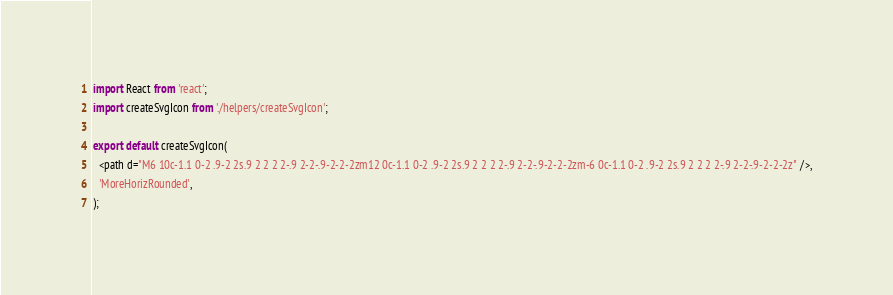Convert code to text. <code><loc_0><loc_0><loc_500><loc_500><_TypeScript_>import React from 'react';
import createSvgIcon from './helpers/createSvgIcon';

export default createSvgIcon(
  <path d="M6 10c-1.1 0-2 .9-2 2s.9 2 2 2 2-.9 2-2-.9-2-2-2zm12 0c-1.1 0-2 .9-2 2s.9 2 2 2 2-.9 2-2-.9-2-2-2zm-6 0c-1.1 0-2 .9-2 2s.9 2 2 2 2-.9 2-2-.9-2-2-2z" />,
  'MoreHorizRounded',
);
</code> 